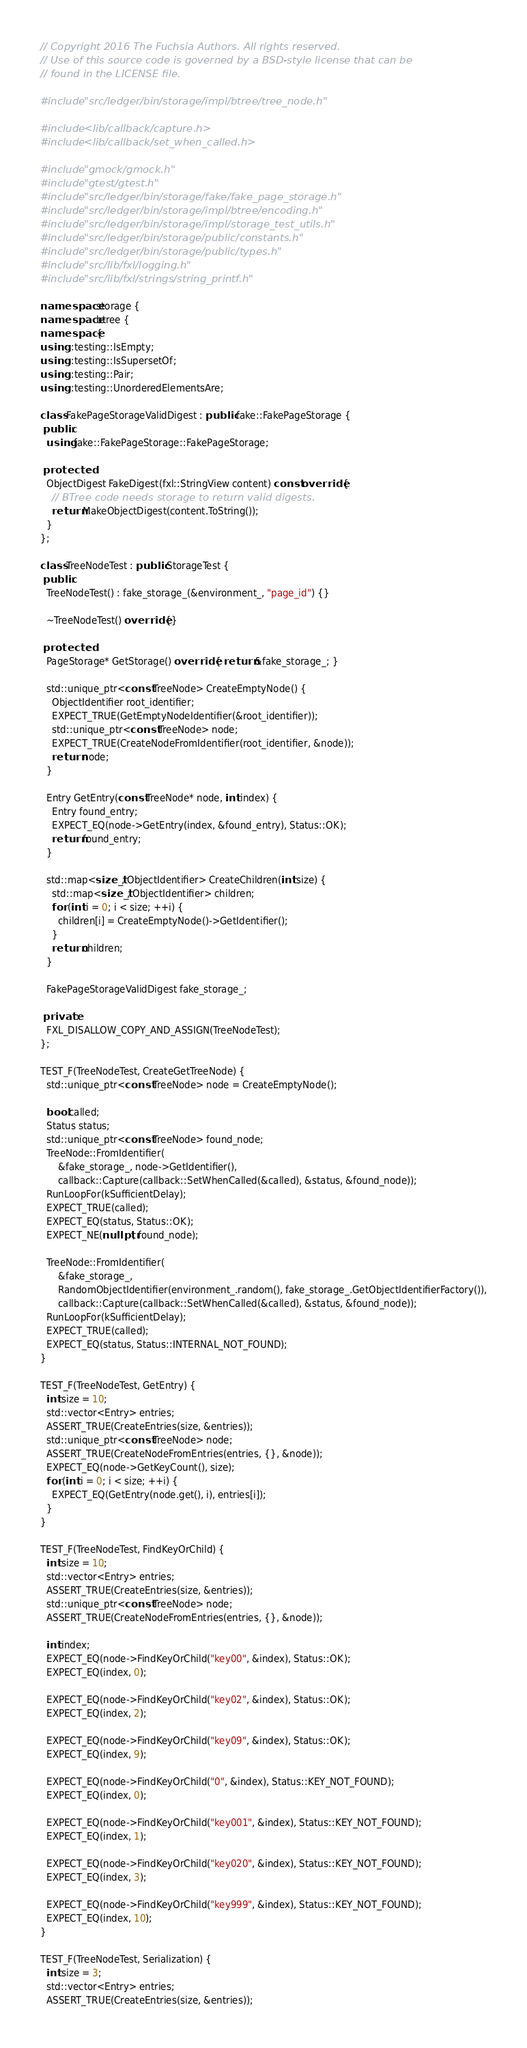<code> <loc_0><loc_0><loc_500><loc_500><_C++_>// Copyright 2016 The Fuchsia Authors. All rights reserved.
// Use of this source code is governed by a BSD-style license that can be
// found in the LICENSE file.

#include "src/ledger/bin/storage/impl/btree/tree_node.h"

#include <lib/callback/capture.h>
#include <lib/callback/set_when_called.h>

#include "gmock/gmock.h"
#include "gtest/gtest.h"
#include "src/ledger/bin/storage/fake/fake_page_storage.h"
#include "src/ledger/bin/storage/impl/btree/encoding.h"
#include "src/ledger/bin/storage/impl/storage_test_utils.h"
#include "src/ledger/bin/storage/public/constants.h"
#include "src/ledger/bin/storage/public/types.h"
#include "src/lib/fxl/logging.h"
#include "src/lib/fxl/strings/string_printf.h"

namespace storage {
namespace btree {
namespace {
using ::testing::IsEmpty;
using ::testing::IsSupersetOf;
using ::testing::Pair;
using ::testing::UnorderedElementsAre;

class FakePageStorageValidDigest : public fake::FakePageStorage {
 public:
  using fake::FakePageStorage::FakePageStorage;

 protected:
  ObjectDigest FakeDigest(fxl::StringView content) const override {
    // BTree code needs storage to return valid digests.
    return MakeObjectDigest(content.ToString());
  }
};

class TreeNodeTest : public StorageTest {
 public:
  TreeNodeTest() : fake_storage_(&environment_, "page_id") {}

  ~TreeNodeTest() override {}

 protected:
  PageStorage* GetStorage() override { return &fake_storage_; }

  std::unique_ptr<const TreeNode> CreateEmptyNode() {
    ObjectIdentifier root_identifier;
    EXPECT_TRUE(GetEmptyNodeIdentifier(&root_identifier));
    std::unique_ptr<const TreeNode> node;
    EXPECT_TRUE(CreateNodeFromIdentifier(root_identifier, &node));
    return node;
  }

  Entry GetEntry(const TreeNode* node, int index) {
    Entry found_entry;
    EXPECT_EQ(node->GetEntry(index, &found_entry), Status::OK);
    return found_entry;
  }

  std::map<size_t, ObjectIdentifier> CreateChildren(int size) {
    std::map<size_t, ObjectIdentifier> children;
    for (int i = 0; i < size; ++i) {
      children[i] = CreateEmptyNode()->GetIdentifier();
    }
    return children;
  }

  FakePageStorageValidDigest fake_storage_;

 private:
  FXL_DISALLOW_COPY_AND_ASSIGN(TreeNodeTest);
};

TEST_F(TreeNodeTest, CreateGetTreeNode) {
  std::unique_ptr<const TreeNode> node = CreateEmptyNode();

  bool called;
  Status status;
  std::unique_ptr<const TreeNode> found_node;
  TreeNode::FromIdentifier(
      &fake_storage_, node->GetIdentifier(),
      callback::Capture(callback::SetWhenCalled(&called), &status, &found_node));
  RunLoopFor(kSufficientDelay);
  EXPECT_TRUE(called);
  EXPECT_EQ(status, Status::OK);
  EXPECT_NE(nullptr, found_node);

  TreeNode::FromIdentifier(
      &fake_storage_,
      RandomObjectIdentifier(environment_.random(), fake_storage_.GetObjectIdentifierFactory()),
      callback::Capture(callback::SetWhenCalled(&called), &status, &found_node));
  RunLoopFor(kSufficientDelay);
  EXPECT_TRUE(called);
  EXPECT_EQ(status, Status::INTERNAL_NOT_FOUND);
}

TEST_F(TreeNodeTest, GetEntry) {
  int size = 10;
  std::vector<Entry> entries;
  ASSERT_TRUE(CreateEntries(size, &entries));
  std::unique_ptr<const TreeNode> node;
  ASSERT_TRUE(CreateNodeFromEntries(entries, {}, &node));
  EXPECT_EQ(node->GetKeyCount(), size);
  for (int i = 0; i < size; ++i) {
    EXPECT_EQ(GetEntry(node.get(), i), entries[i]);
  }
}

TEST_F(TreeNodeTest, FindKeyOrChild) {
  int size = 10;
  std::vector<Entry> entries;
  ASSERT_TRUE(CreateEntries(size, &entries));
  std::unique_ptr<const TreeNode> node;
  ASSERT_TRUE(CreateNodeFromEntries(entries, {}, &node));

  int index;
  EXPECT_EQ(node->FindKeyOrChild("key00", &index), Status::OK);
  EXPECT_EQ(index, 0);

  EXPECT_EQ(node->FindKeyOrChild("key02", &index), Status::OK);
  EXPECT_EQ(index, 2);

  EXPECT_EQ(node->FindKeyOrChild("key09", &index), Status::OK);
  EXPECT_EQ(index, 9);

  EXPECT_EQ(node->FindKeyOrChild("0", &index), Status::KEY_NOT_FOUND);
  EXPECT_EQ(index, 0);

  EXPECT_EQ(node->FindKeyOrChild("key001", &index), Status::KEY_NOT_FOUND);
  EXPECT_EQ(index, 1);

  EXPECT_EQ(node->FindKeyOrChild("key020", &index), Status::KEY_NOT_FOUND);
  EXPECT_EQ(index, 3);

  EXPECT_EQ(node->FindKeyOrChild("key999", &index), Status::KEY_NOT_FOUND);
  EXPECT_EQ(index, 10);
}

TEST_F(TreeNodeTest, Serialization) {
  int size = 3;
  std::vector<Entry> entries;
  ASSERT_TRUE(CreateEntries(size, &entries));</code> 